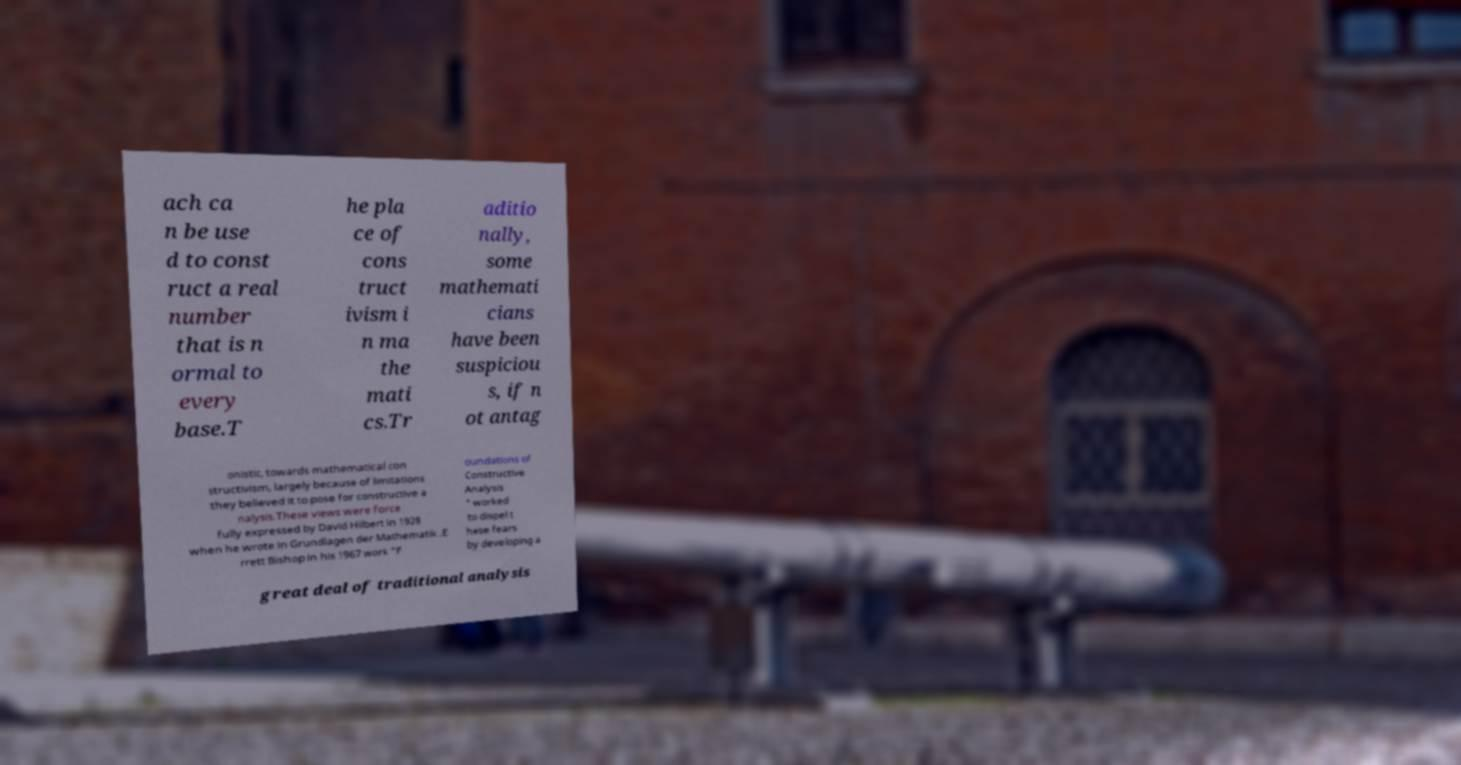Can you accurately transcribe the text from the provided image for me? ach ca n be use d to const ruct a real number that is n ormal to every base.T he pla ce of cons truct ivism i n ma the mati cs.Tr aditio nally, some mathemati cians have been suspiciou s, if n ot antag onistic, towards mathematical con structivism, largely because of limitations they believed it to pose for constructive a nalysis.These views were force fully expressed by David Hilbert in 1928 when he wrote in Grundlagen der Mathematik .E rrett Bishop in his 1967 work "F oundations of Constructive Analysis " worked to dispel t hese fears by developing a great deal of traditional analysis 